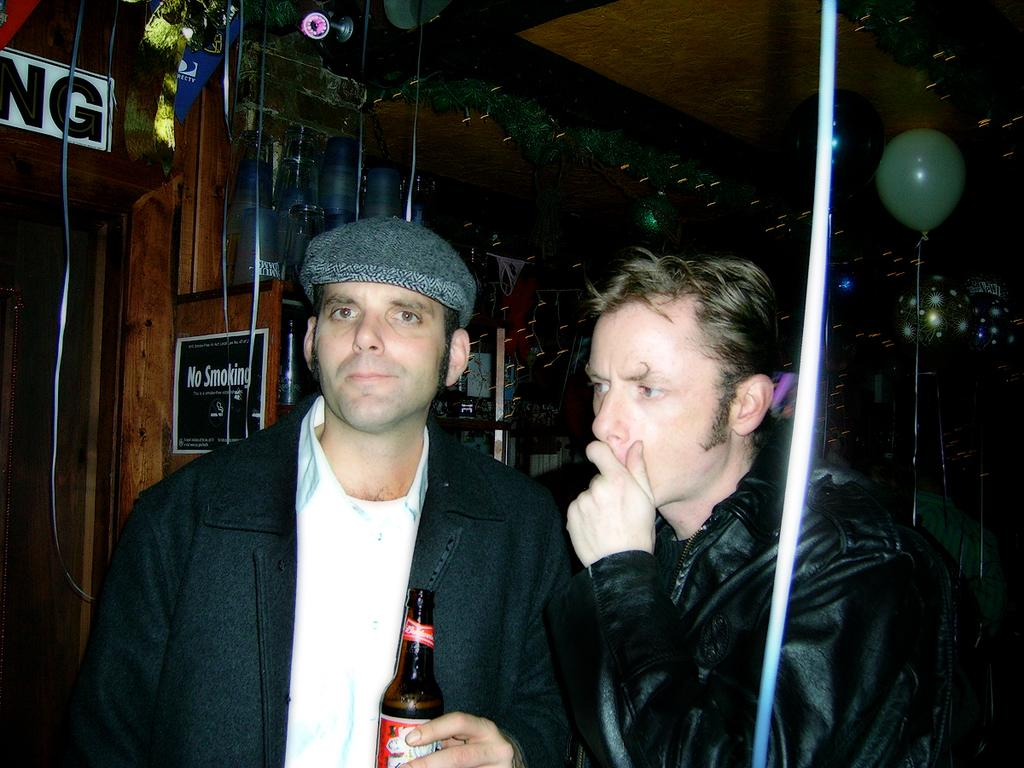How many people are in the image? There are two people in the image. What is one of the people wearing? One of the people is wearing a cap. What is the person wearing a cap holding? The person wearing a cap is holding a bottle. What can be seen in the background of the image? There are boards and a balloon visible in the background of the image. How does the person wearing a cap show respect to the other person in the image? There is no indication in the image of the person wearing a cap showing respect to the other person. 